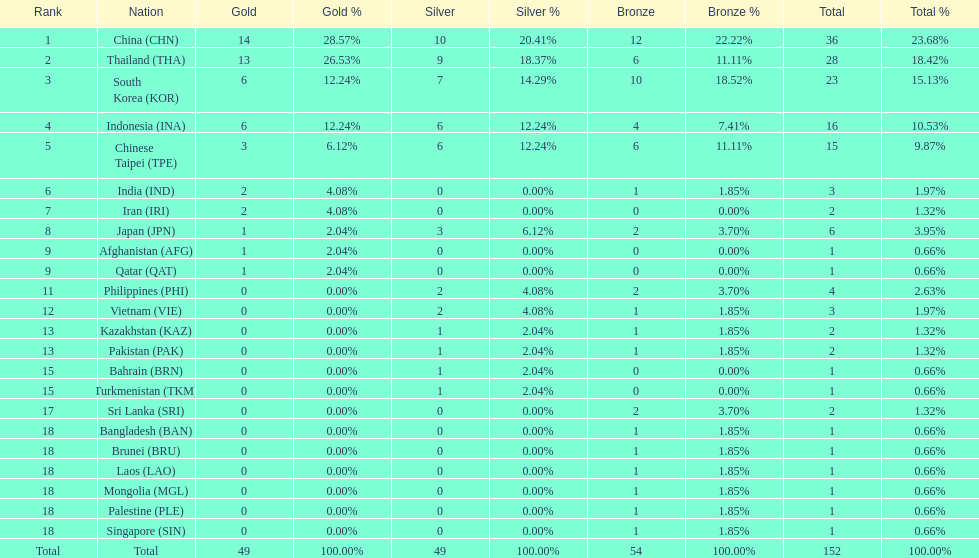Could you help me parse every detail presented in this table? {'header': ['Rank', 'Nation', 'Gold', 'Gold %', 'Silver', 'Silver %', 'Bronze', 'Bronze %', 'Total', 'Total %'], 'rows': [['1', 'China\xa0(CHN)', '14', '28.57%', '10', '20.41%', '12', '22.22%', '36', '23.68%'], ['2', 'Thailand\xa0(THA)', '13', '26.53%', '9', '18.37%', '6', '11.11%', '28', '18.42%'], ['3', 'South Korea\xa0(KOR)', '6', '12.24%', '7', '14.29%', '10', '18.52%', '23', '15.13%'], ['4', 'Indonesia\xa0(INA)', '6', '12.24%', '6', '12.24%', '4', '7.41%', '16', '10.53%'], ['5', 'Chinese Taipei\xa0(TPE)', '3', '6.12%', '6', '12.24%', '6', '11.11%', '15', '9.87%'], ['6', 'India\xa0(IND)', '2', '4.08%', '0', '0.00%', '1', '1.85%', '3', '1.97%'], ['7', 'Iran\xa0(IRI)', '2', '4.08%', '0', '0.00%', '0', '0.00%', '2', '1.32%'], ['8', 'Japan\xa0(JPN)', '1', '2.04%', '3', '6.12%', '2', '3.70%', '6', '3.95%'], ['9', 'Afghanistan\xa0(AFG)', '1', '2.04%', '0', '0.00%', '0', '0.00%', '1', '0.66%'], ['9', 'Qatar\xa0(QAT)', '1', '2.04%', '0', '0.00%', '0', '0.00%', '1', '0.66%'], ['11', 'Philippines\xa0(PHI)', '0', '0.00%', '2', '4.08%', '2', '3.70%', '4', '2.63%'], ['12', 'Vietnam\xa0(VIE)', '0', '0.00%', '2', '4.08%', '1', '1.85%', '3', '1.97%'], ['13', 'Kazakhstan\xa0(KAZ)', '0', '0.00%', '1', '2.04%', '1', '1.85%', '2', '1.32%'], ['13', 'Pakistan\xa0(PAK)', '0', '0.00%', '1', '2.04%', '1', '1.85%', '2', '1.32%'], ['15', 'Bahrain\xa0(BRN)', '0', '0.00%', '1', '2.04%', '0', '0.00%', '1', '0.66%'], ['15', 'Turkmenistan\xa0(TKM)', '0', '0.00%', '1', '2.04%', '0', '0.00%', '1', '0.66%'], ['17', 'Sri Lanka\xa0(SRI)', '0', '0.00%', '0', '0.00%', '2', '3.70%', '2', '1.32%'], ['18', 'Bangladesh\xa0(BAN)', '0', '0.00%', '0', '0.00%', '1', '1.85%', '1', '0.66%'], ['18', 'Brunei\xa0(BRU)', '0', '0.00%', '0', '0.00%', '1', '1.85%', '1', '0.66%'], ['18', 'Laos\xa0(LAO)', '0', '0.00%', '0', '0.00%', '1', '1.85%', '1', '0.66%'], ['18', 'Mongolia\xa0(MGL)', '0', '0.00%', '0', '0.00%', '1', '1.85%', '1', '0.66%'], ['18', 'Palestine\xa0(PLE)', '0', '0.00%', '0', '0.00%', '1', '1.85%', '1', '0.66%'], ['18', 'Singapore\xa0(SIN)', '0', '0.00%', '0', '0.00%', '1', '1.85%', '1', '0.66%'], ['Total', 'Total', '49', '100.00%', '49', '100.00%', '54', '100.00%', '152', '100.00%']]} How many nations received a medal in each gold, silver, and bronze? 6. 